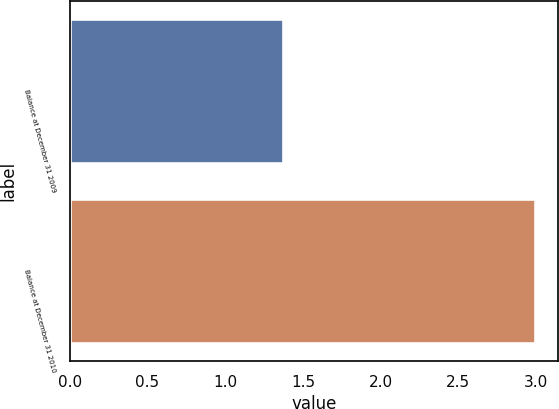<chart> <loc_0><loc_0><loc_500><loc_500><bar_chart><fcel>Balance at December 31 2009<fcel>Balance at December 31 2010<nl><fcel>1.37<fcel>2.99<nl></chart> 